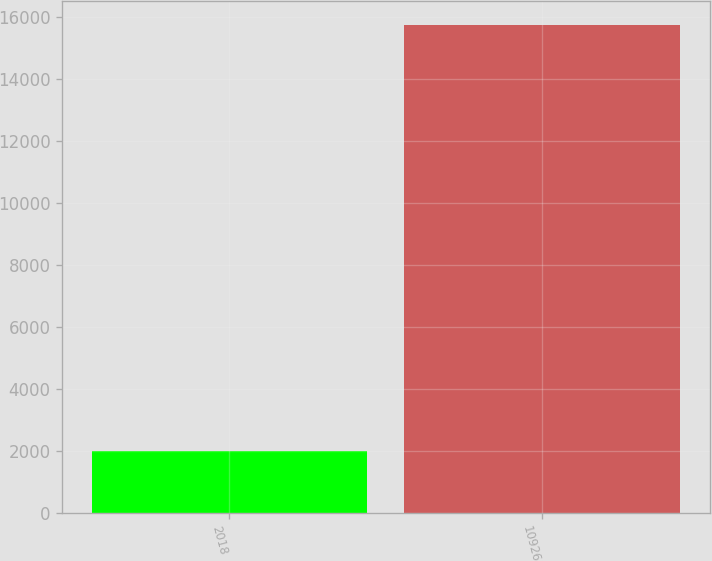Convert chart to OTSL. <chart><loc_0><loc_0><loc_500><loc_500><bar_chart><fcel>2018<fcel>10926<nl><fcel>2016<fcel>15749<nl></chart> 